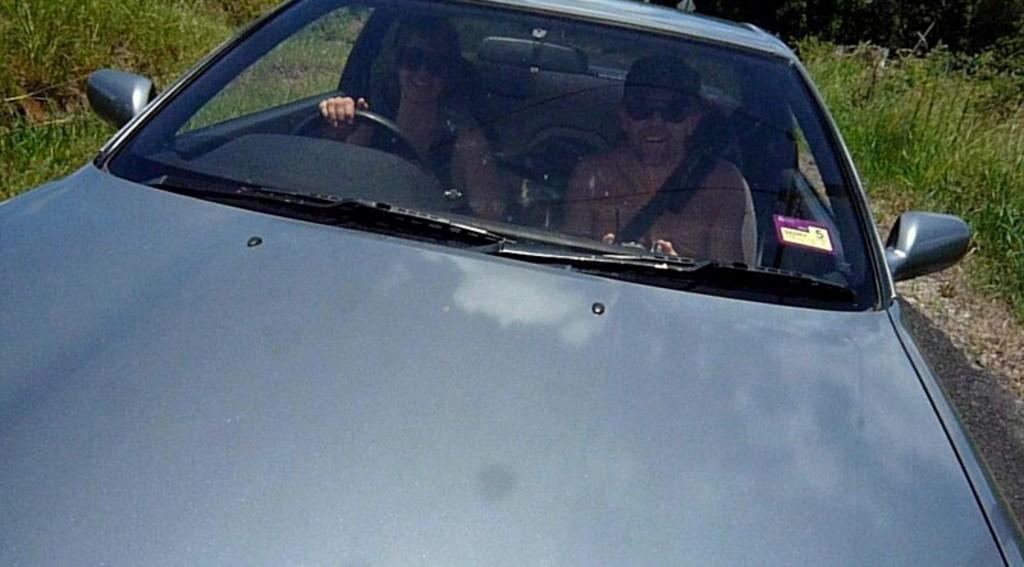How would you summarize this image in a sentence or two? In the image we can see the vehicle and in the vehicle there are two people sitting, wearing clothes and goggles. Here we can see the steering part and the grass. 